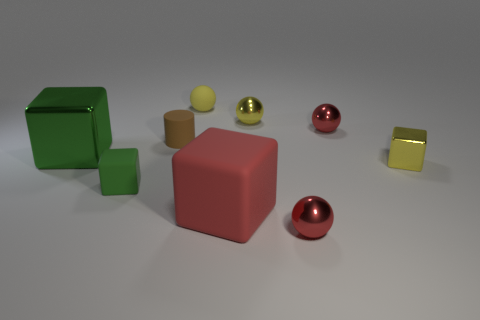There is a cube that is on the right side of the large red block; what is its color?
Give a very brief answer. Yellow. Are there the same number of small green matte blocks that are behind the tiny yellow rubber ball and big red shiny balls?
Your answer should be compact. Yes. How many other objects are the same shape as the green shiny thing?
Make the answer very short. 3. There is a small yellow rubber object; what number of metallic balls are in front of it?
Your response must be concise. 3. There is a sphere that is both in front of the tiny yellow metal sphere and behind the small green rubber cube; what is its size?
Your answer should be very brief. Small. Is there a big brown thing?
Your answer should be compact. No. How many other things are the same size as the yellow metallic ball?
Give a very brief answer. 6. There is a tiny shiny sphere in front of the red block; does it have the same color as the big thing in front of the large green metallic cube?
Offer a terse response. Yes. The yellow shiny object that is the same shape as the large red thing is what size?
Keep it short and to the point. Small. Do the tiny red thing that is behind the tiny rubber block and the tiny yellow ball that is to the right of the rubber sphere have the same material?
Your response must be concise. Yes. 